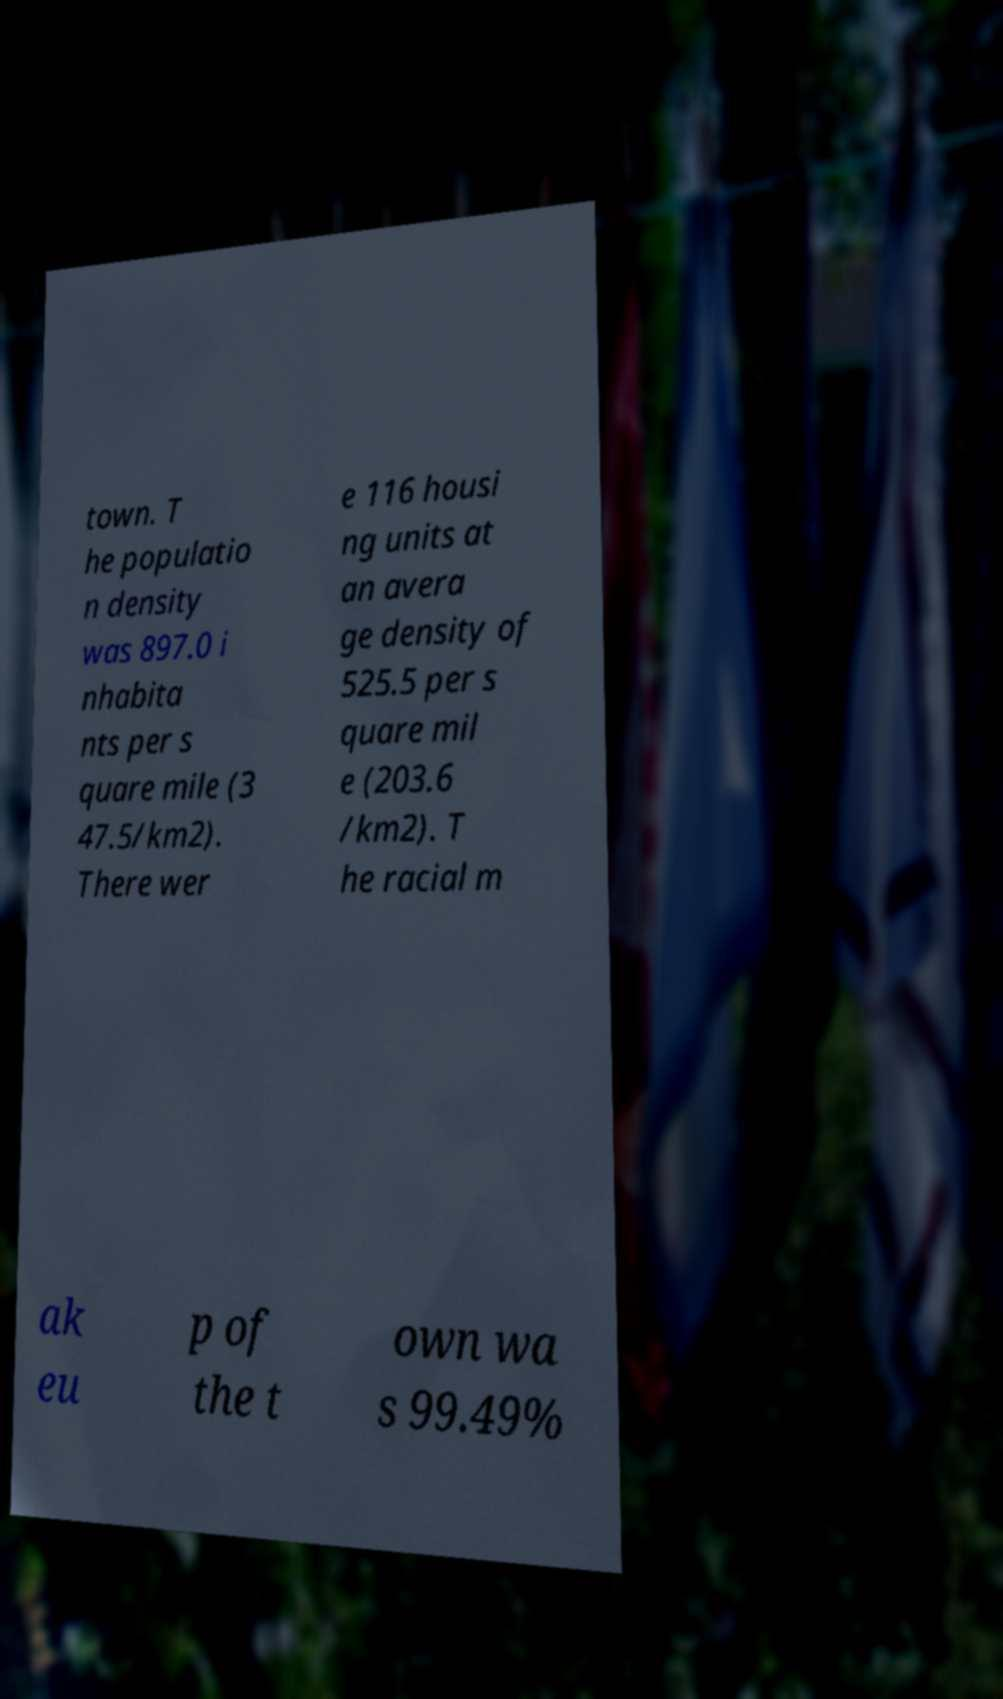Can you read and provide the text displayed in the image?This photo seems to have some interesting text. Can you extract and type it out for me? town. T he populatio n density was 897.0 i nhabita nts per s quare mile (3 47.5/km2). There wer e 116 housi ng units at an avera ge density of 525.5 per s quare mil e (203.6 /km2). T he racial m ak eu p of the t own wa s 99.49% 